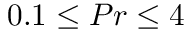<formula> <loc_0><loc_0><loc_500><loc_500>0 . 1 \leq P r \leq 4</formula> 